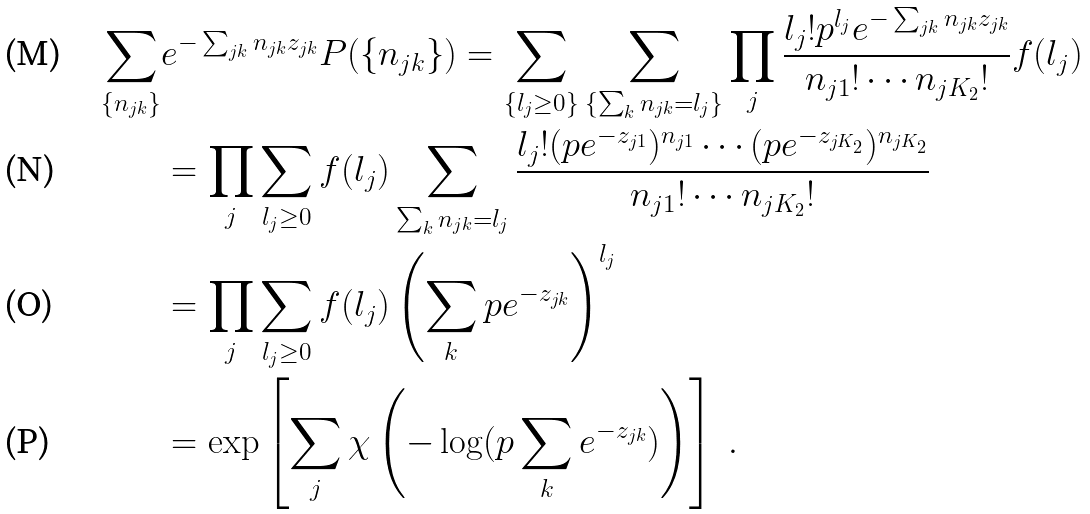Convert formula to latex. <formula><loc_0><loc_0><loc_500><loc_500>\sum _ { \{ n _ { j k } \} } & e ^ { - \sum _ { j k } n _ { j k } z _ { j k } } P ( \{ n _ { j k } \} ) = \sum _ { \{ l _ { j } \geq 0 \} } \sum _ { \{ \sum _ { k } n _ { j k } = l _ { j } \} } \prod _ { j } \frac { l _ { j } ! p ^ { l _ { j } } e ^ { - \sum _ { j k } n _ { j k } z _ { j k } } } { n _ { j 1 } ! \cdots n _ { j K _ { 2 } } ! } f ( l _ { j } ) \\ & = \prod _ { j } \sum _ { l _ { j } \geq 0 } f ( l _ { j } ) \sum _ { \sum _ { k } n _ { j k } = l _ { j } } \frac { l _ { j } ! ( p e ^ { - z _ { j 1 } } ) ^ { n _ { j 1 } } \cdots ( p e ^ { - z _ { j K _ { 2 } } } ) ^ { n _ { j K _ { 2 } } } } { n _ { j 1 } ! \cdots n _ { j K _ { 2 } } ! } \\ & = \prod _ { j } \sum _ { l _ { j } \geq 0 } f ( l _ { j } ) \left ( \sum _ { k } p e ^ { - z _ { j k } } \right ) ^ { l _ { j } } \\ & = \exp \left [ \sum _ { j } \chi \left ( - \log ( p \sum _ { k } e ^ { - z _ { j k } } ) \right ) \right ] \ .</formula> 